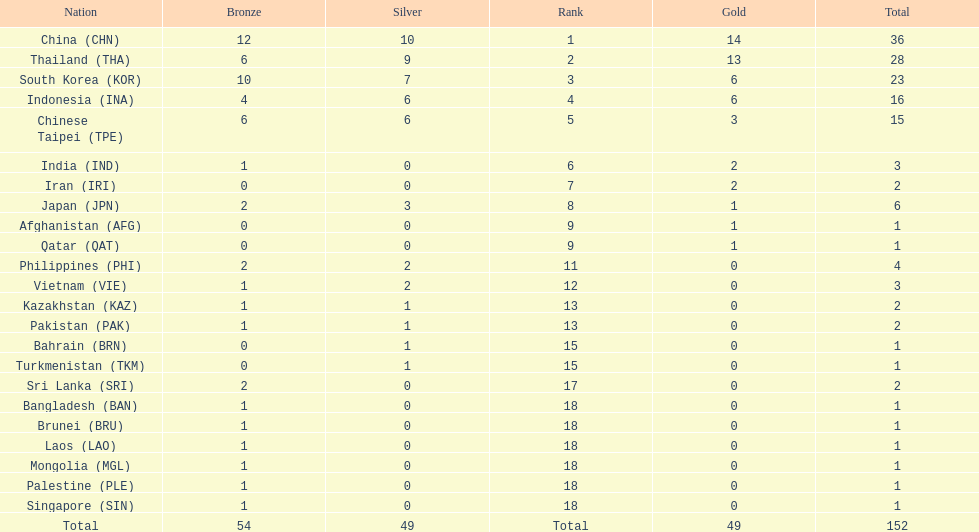Which countries won the same number of gold medals as japan? Afghanistan (AFG), Qatar (QAT). 